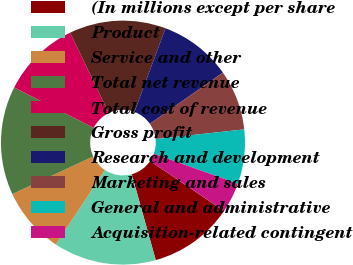Convert chart. <chart><loc_0><loc_0><loc_500><loc_500><pie_chart><fcel>(In millions except per share<fcel>Product<fcel>Service and other<fcel>Total net revenue<fcel>Total cost of revenue<fcel>Gross profit<fcel>Research and development<fcel>Marketing and sales<fcel>General and administrative<fcel>Acquisition-related contingent<nl><fcel>11.2%<fcel>13.6%<fcel>8.8%<fcel>14.4%<fcel>10.4%<fcel>12.8%<fcel>9.6%<fcel>8.0%<fcel>7.2%<fcel>4.0%<nl></chart> 